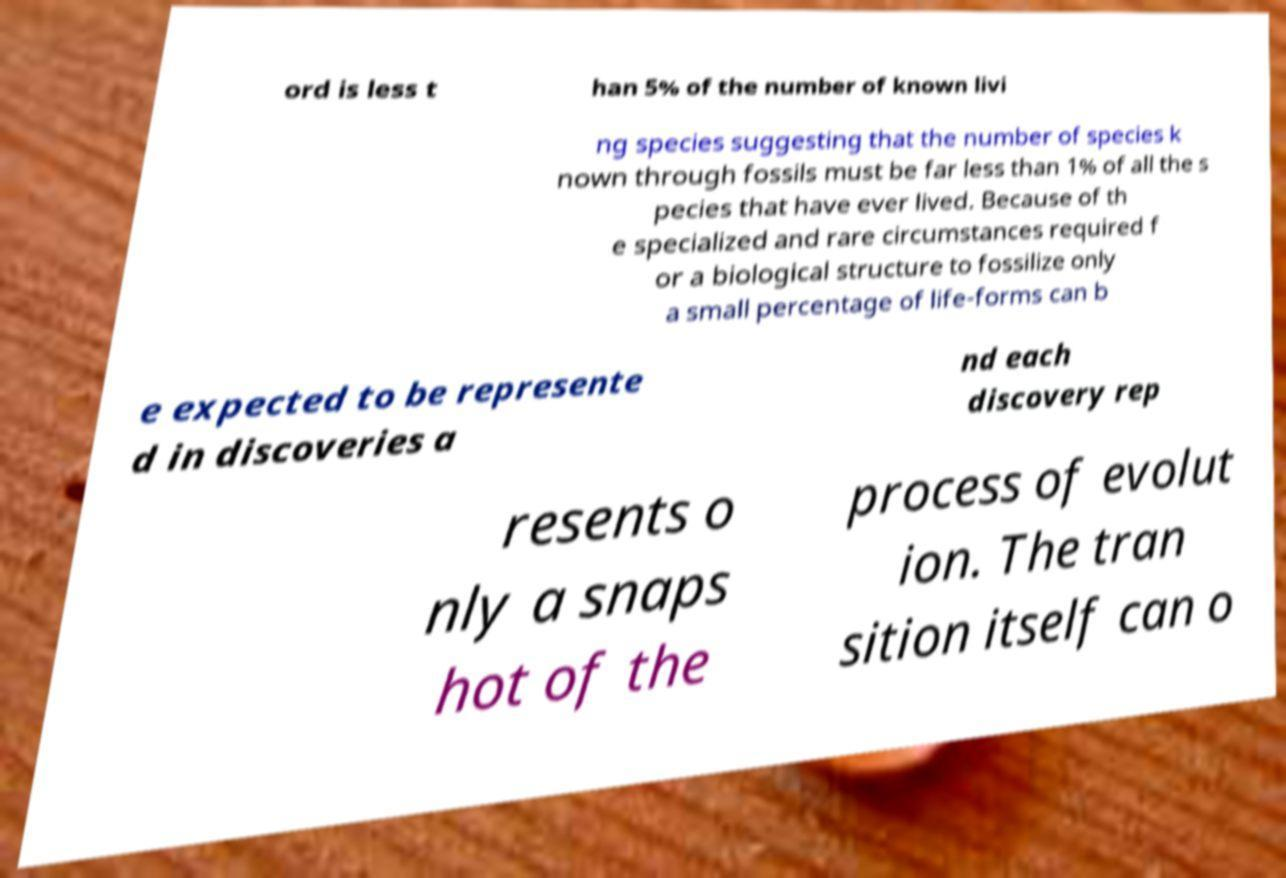Could you extract and type out the text from this image? ord is less t han 5% of the number of known livi ng species suggesting that the number of species k nown through fossils must be far less than 1% of all the s pecies that have ever lived. Because of th e specialized and rare circumstances required f or a biological structure to fossilize only a small percentage of life-forms can b e expected to be represente d in discoveries a nd each discovery rep resents o nly a snaps hot of the process of evolut ion. The tran sition itself can o 